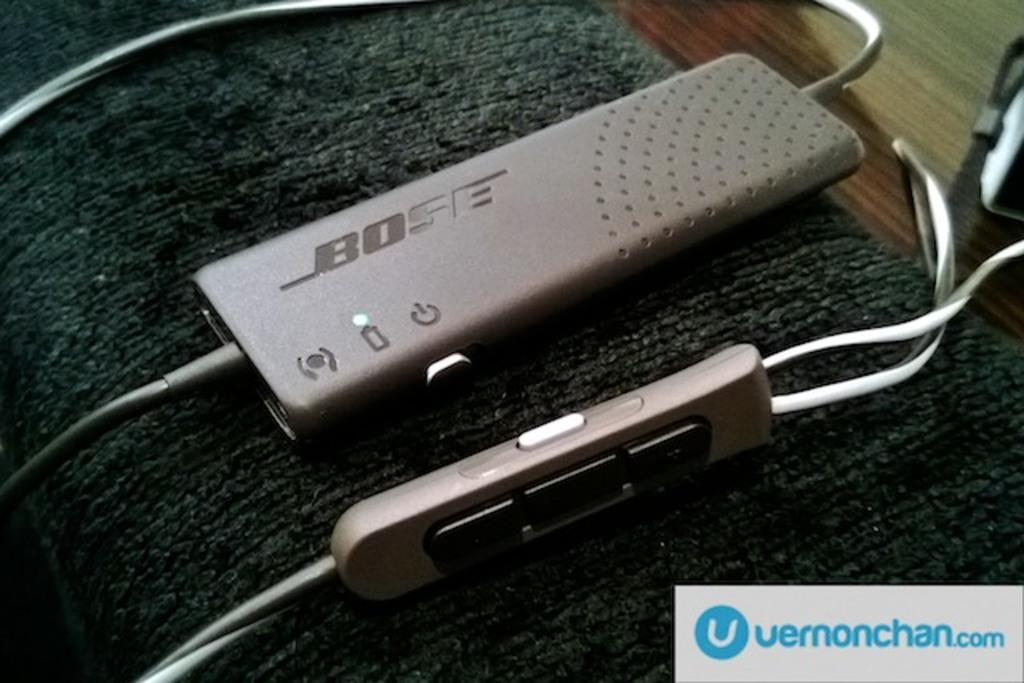<image>
Share a concise interpretation of the image provided. Gray Bose device being charged on a sofa. 